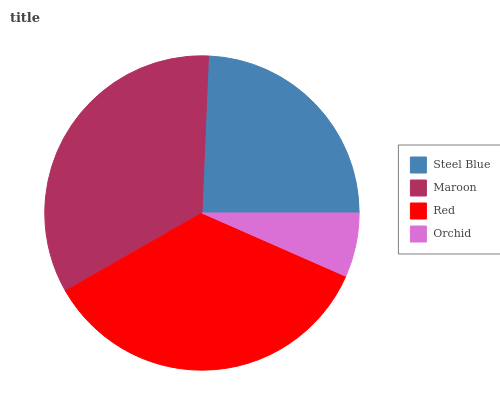Is Orchid the minimum?
Answer yes or no. Yes. Is Red the maximum?
Answer yes or no. Yes. Is Maroon the minimum?
Answer yes or no. No. Is Maroon the maximum?
Answer yes or no. No. Is Maroon greater than Steel Blue?
Answer yes or no. Yes. Is Steel Blue less than Maroon?
Answer yes or no. Yes. Is Steel Blue greater than Maroon?
Answer yes or no. No. Is Maroon less than Steel Blue?
Answer yes or no. No. Is Maroon the high median?
Answer yes or no. Yes. Is Steel Blue the low median?
Answer yes or no. Yes. Is Orchid the high median?
Answer yes or no. No. Is Maroon the low median?
Answer yes or no. No. 